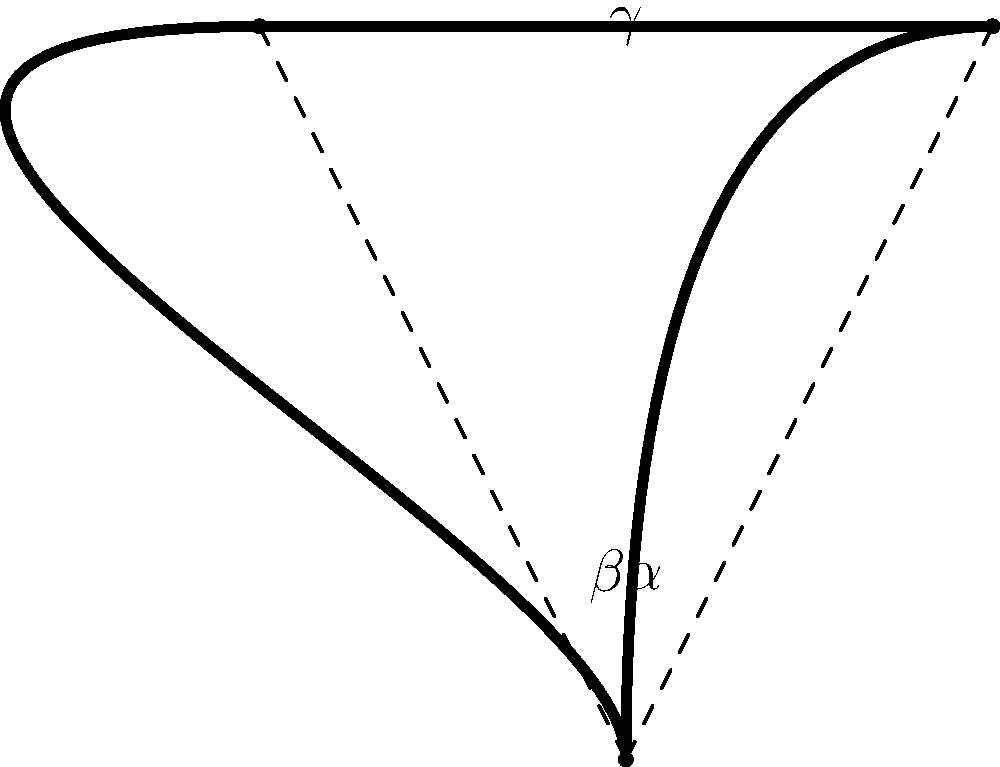In this simplified representation of Homer Simpson's iconic hairstyle, the two strands of hair form a triangle. If the angle $\alpha$ between the right strand and the vertical axis is 30°, and the angle $\gamma$ at the top of the hair is 60°, what is the measure of angle $\beta$ between the left strand and the vertical axis? Let's approach this step-by-step:

1) In any triangle, the sum of all interior angles is always 180°. We can express this as:

   $$\alpha + \beta + \gamma = 180°$$

2) We are given two pieces of information:
   - $\alpha = 30°$
   - $\gamma = 60°$

3) Let's substitute these known values into our equation:

   $$30° + \beta + 60° = 180°$$

4) Simplify:

   $$90° + \beta = 180°$$

5) Subtract 90° from both sides:

   $$\beta = 180° - 90° = 90°$$

Therefore, the measure of angle $\beta$ is 90°.
Answer: 90° 